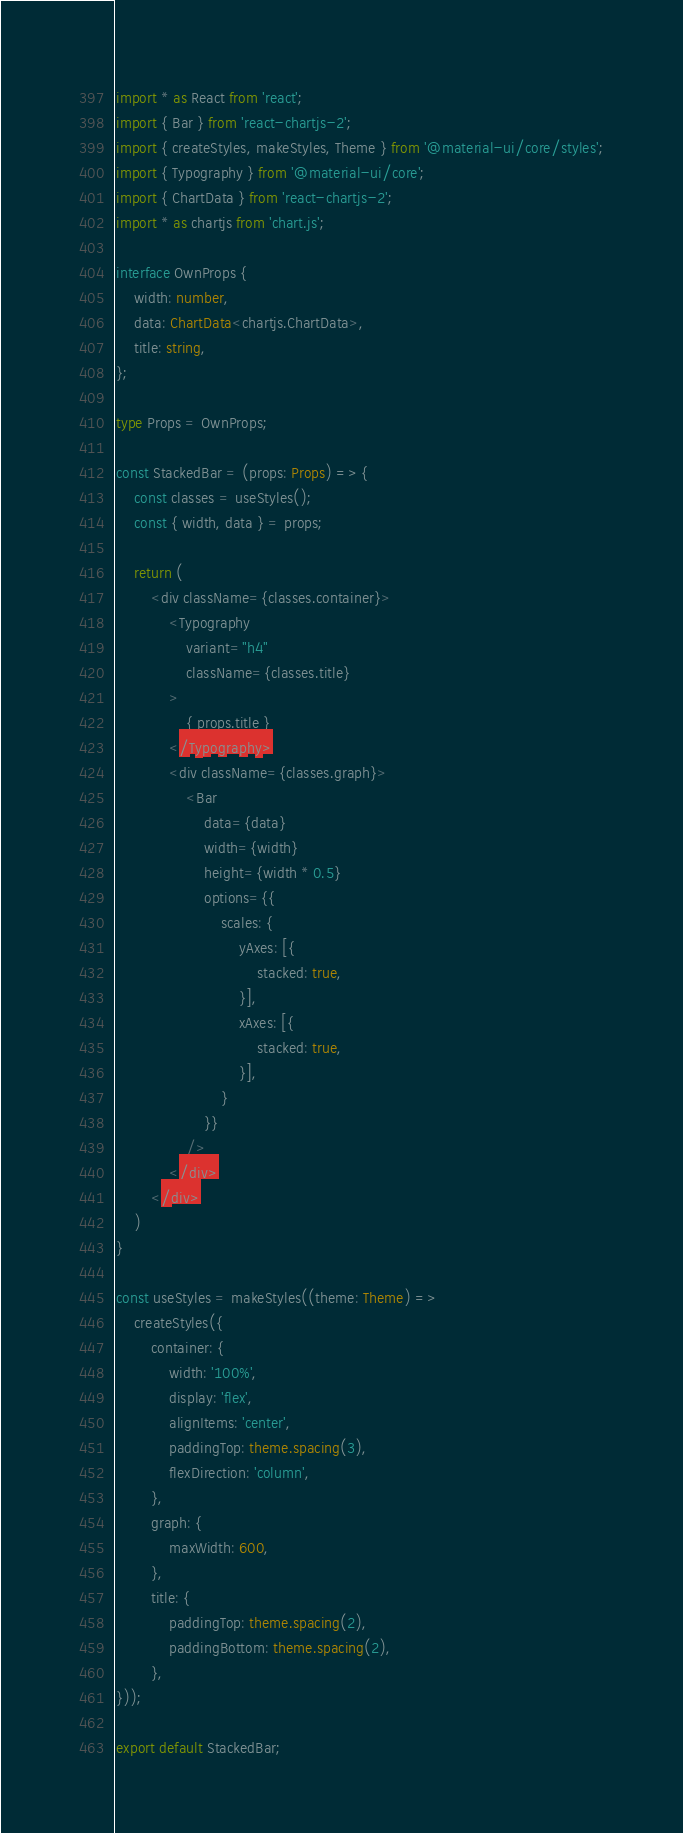<code> <loc_0><loc_0><loc_500><loc_500><_TypeScript_>import * as React from 'react';
import { Bar } from 'react-chartjs-2';
import { createStyles, makeStyles, Theme } from '@material-ui/core/styles';
import { Typography } from '@material-ui/core';
import { ChartData } from 'react-chartjs-2';
import * as chartjs from 'chart.js';

interface OwnProps {
    width: number,
    data: ChartData<chartjs.ChartData>,
    title: string,
};

type Props = OwnProps;

const StackedBar = (props: Props) => {
    const classes = useStyles();
    const { width, data } = props;

    return (
        <div className={classes.container}>
            <Typography
                variant="h4"
                className={classes.title}
            >
                { props.title }
            </Typography>
            <div className={classes.graph}>
                <Bar
                    data={data}
                    width={width}
                    height={width * 0.5}
                    options={{
                        scales: {
                            yAxes: [{
                                stacked: true,
                            }],
                            xAxes: [{
                                stacked: true,
                            }],
                        }
                    }}
                />
            </div>
        </div>
    )
}

const useStyles = makeStyles((theme: Theme) =>
    createStyles({
        container: {
            width: '100%',
            display: 'flex',
            alignItems: 'center',
            paddingTop: theme.spacing(3),
            flexDirection: 'column',
        },
        graph: {
            maxWidth: 600,
        },
        title: {
            paddingTop: theme.spacing(2),
            paddingBottom: theme.spacing(2),
        },
}));

export default StackedBar;
</code> 